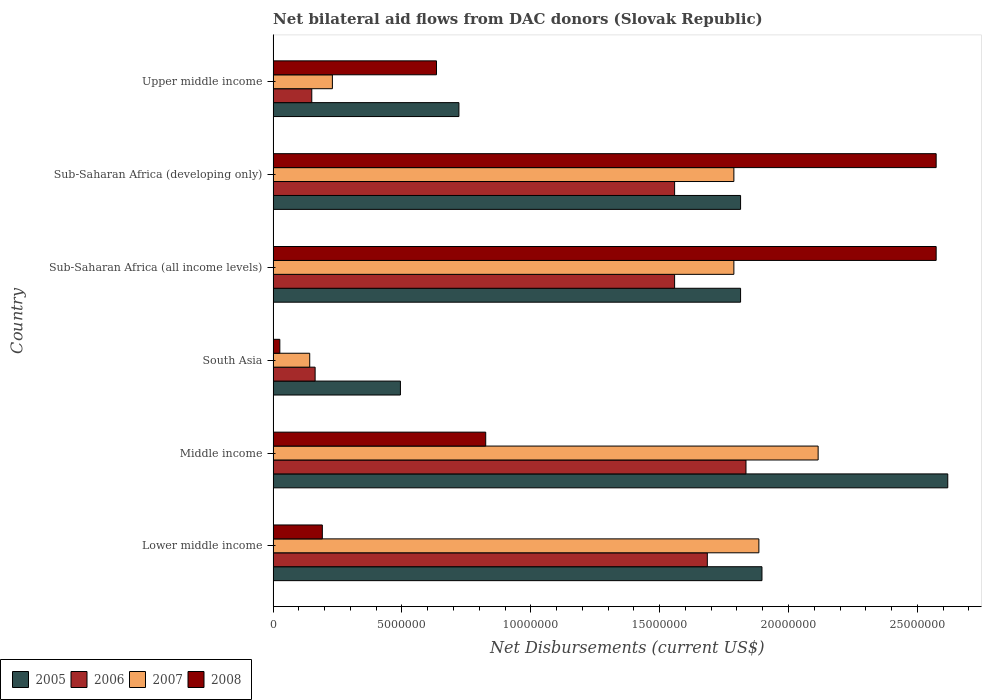How many different coloured bars are there?
Ensure brevity in your answer.  4. Are the number of bars on each tick of the Y-axis equal?
Keep it short and to the point. Yes. In how many cases, is the number of bars for a given country not equal to the number of legend labels?
Ensure brevity in your answer.  0. What is the net bilateral aid flows in 2005 in Upper middle income?
Your response must be concise. 7.21e+06. Across all countries, what is the maximum net bilateral aid flows in 2006?
Your answer should be compact. 1.84e+07. Across all countries, what is the minimum net bilateral aid flows in 2006?
Keep it short and to the point. 1.50e+06. In which country was the net bilateral aid flows in 2006 maximum?
Make the answer very short. Middle income. What is the total net bilateral aid flows in 2007 in the graph?
Offer a very short reply. 7.95e+07. What is the difference between the net bilateral aid flows in 2007 in South Asia and that in Sub-Saharan Africa (all income levels)?
Give a very brief answer. -1.65e+07. What is the difference between the net bilateral aid flows in 2008 in Sub-Saharan Africa (developing only) and the net bilateral aid flows in 2006 in Middle income?
Ensure brevity in your answer.  7.38e+06. What is the average net bilateral aid flows in 2007 per country?
Provide a short and direct response. 1.32e+07. What is the difference between the net bilateral aid flows in 2005 and net bilateral aid flows in 2007 in Sub-Saharan Africa (developing only)?
Provide a short and direct response. 2.60e+05. What is the ratio of the net bilateral aid flows in 2007 in Sub-Saharan Africa (developing only) to that in Upper middle income?
Your response must be concise. 7.77. Is the net bilateral aid flows in 2008 in Sub-Saharan Africa (all income levels) less than that in Sub-Saharan Africa (developing only)?
Make the answer very short. No. Is the difference between the net bilateral aid flows in 2005 in Middle income and Sub-Saharan Africa (all income levels) greater than the difference between the net bilateral aid flows in 2007 in Middle income and Sub-Saharan Africa (all income levels)?
Ensure brevity in your answer.  Yes. What is the difference between the highest and the second highest net bilateral aid flows in 2008?
Provide a short and direct response. 0. What is the difference between the highest and the lowest net bilateral aid flows in 2008?
Make the answer very short. 2.55e+07. In how many countries, is the net bilateral aid flows in 2005 greater than the average net bilateral aid flows in 2005 taken over all countries?
Give a very brief answer. 4. Is it the case that in every country, the sum of the net bilateral aid flows in 2008 and net bilateral aid flows in 2007 is greater than the sum of net bilateral aid flows in 2006 and net bilateral aid flows in 2005?
Offer a very short reply. No. What does the 3rd bar from the top in Sub-Saharan Africa (all income levels) represents?
Keep it short and to the point. 2006. What does the 3rd bar from the bottom in Upper middle income represents?
Make the answer very short. 2007. How many bars are there?
Your response must be concise. 24. How many countries are there in the graph?
Give a very brief answer. 6. Are the values on the major ticks of X-axis written in scientific E-notation?
Your response must be concise. No. Does the graph contain grids?
Offer a very short reply. No. Where does the legend appear in the graph?
Provide a succinct answer. Bottom left. How many legend labels are there?
Provide a succinct answer. 4. How are the legend labels stacked?
Offer a terse response. Horizontal. What is the title of the graph?
Keep it short and to the point. Net bilateral aid flows from DAC donors (Slovak Republic). What is the label or title of the X-axis?
Your answer should be compact. Net Disbursements (current US$). What is the Net Disbursements (current US$) in 2005 in Lower middle income?
Make the answer very short. 1.90e+07. What is the Net Disbursements (current US$) in 2006 in Lower middle income?
Your answer should be compact. 1.68e+07. What is the Net Disbursements (current US$) of 2007 in Lower middle income?
Keep it short and to the point. 1.88e+07. What is the Net Disbursements (current US$) in 2008 in Lower middle income?
Offer a very short reply. 1.91e+06. What is the Net Disbursements (current US$) of 2005 in Middle income?
Give a very brief answer. 2.62e+07. What is the Net Disbursements (current US$) of 2006 in Middle income?
Keep it short and to the point. 1.84e+07. What is the Net Disbursements (current US$) of 2007 in Middle income?
Give a very brief answer. 2.12e+07. What is the Net Disbursements (current US$) of 2008 in Middle income?
Keep it short and to the point. 8.25e+06. What is the Net Disbursements (current US$) of 2005 in South Asia?
Ensure brevity in your answer.  4.94e+06. What is the Net Disbursements (current US$) in 2006 in South Asia?
Give a very brief answer. 1.63e+06. What is the Net Disbursements (current US$) of 2007 in South Asia?
Your answer should be very brief. 1.42e+06. What is the Net Disbursements (current US$) in 2008 in South Asia?
Your answer should be very brief. 2.60e+05. What is the Net Disbursements (current US$) of 2005 in Sub-Saharan Africa (all income levels)?
Offer a very short reply. 1.81e+07. What is the Net Disbursements (current US$) in 2006 in Sub-Saharan Africa (all income levels)?
Make the answer very short. 1.56e+07. What is the Net Disbursements (current US$) of 2007 in Sub-Saharan Africa (all income levels)?
Your answer should be very brief. 1.79e+07. What is the Net Disbursements (current US$) of 2008 in Sub-Saharan Africa (all income levels)?
Your response must be concise. 2.57e+07. What is the Net Disbursements (current US$) in 2005 in Sub-Saharan Africa (developing only)?
Your answer should be very brief. 1.81e+07. What is the Net Disbursements (current US$) of 2006 in Sub-Saharan Africa (developing only)?
Offer a very short reply. 1.56e+07. What is the Net Disbursements (current US$) in 2007 in Sub-Saharan Africa (developing only)?
Your answer should be compact. 1.79e+07. What is the Net Disbursements (current US$) in 2008 in Sub-Saharan Africa (developing only)?
Your answer should be very brief. 2.57e+07. What is the Net Disbursements (current US$) in 2005 in Upper middle income?
Make the answer very short. 7.21e+06. What is the Net Disbursements (current US$) in 2006 in Upper middle income?
Your answer should be very brief. 1.50e+06. What is the Net Disbursements (current US$) in 2007 in Upper middle income?
Provide a succinct answer. 2.30e+06. What is the Net Disbursements (current US$) in 2008 in Upper middle income?
Offer a terse response. 6.34e+06. Across all countries, what is the maximum Net Disbursements (current US$) in 2005?
Your answer should be very brief. 2.62e+07. Across all countries, what is the maximum Net Disbursements (current US$) in 2006?
Make the answer very short. 1.84e+07. Across all countries, what is the maximum Net Disbursements (current US$) in 2007?
Your response must be concise. 2.12e+07. Across all countries, what is the maximum Net Disbursements (current US$) in 2008?
Give a very brief answer. 2.57e+07. Across all countries, what is the minimum Net Disbursements (current US$) of 2005?
Your answer should be compact. 4.94e+06. Across all countries, what is the minimum Net Disbursements (current US$) of 2006?
Your answer should be compact. 1.50e+06. Across all countries, what is the minimum Net Disbursements (current US$) of 2007?
Your answer should be very brief. 1.42e+06. Across all countries, what is the minimum Net Disbursements (current US$) of 2008?
Offer a terse response. 2.60e+05. What is the total Net Disbursements (current US$) in 2005 in the graph?
Your response must be concise. 9.36e+07. What is the total Net Disbursements (current US$) in 2006 in the graph?
Offer a terse response. 6.95e+07. What is the total Net Disbursements (current US$) of 2007 in the graph?
Provide a succinct answer. 7.95e+07. What is the total Net Disbursements (current US$) in 2008 in the graph?
Keep it short and to the point. 6.82e+07. What is the difference between the Net Disbursements (current US$) in 2005 in Lower middle income and that in Middle income?
Offer a very short reply. -7.21e+06. What is the difference between the Net Disbursements (current US$) in 2006 in Lower middle income and that in Middle income?
Your answer should be compact. -1.50e+06. What is the difference between the Net Disbursements (current US$) in 2007 in Lower middle income and that in Middle income?
Your answer should be very brief. -2.30e+06. What is the difference between the Net Disbursements (current US$) of 2008 in Lower middle income and that in Middle income?
Offer a terse response. -6.34e+06. What is the difference between the Net Disbursements (current US$) of 2005 in Lower middle income and that in South Asia?
Keep it short and to the point. 1.40e+07. What is the difference between the Net Disbursements (current US$) in 2006 in Lower middle income and that in South Asia?
Provide a short and direct response. 1.52e+07. What is the difference between the Net Disbursements (current US$) of 2007 in Lower middle income and that in South Asia?
Your response must be concise. 1.74e+07. What is the difference between the Net Disbursements (current US$) of 2008 in Lower middle income and that in South Asia?
Provide a short and direct response. 1.65e+06. What is the difference between the Net Disbursements (current US$) of 2005 in Lower middle income and that in Sub-Saharan Africa (all income levels)?
Make the answer very short. 8.30e+05. What is the difference between the Net Disbursements (current US$) of 2006 in Lower middle income and that in Sub-Saharan Africa (all income levels)?
Your answer should be compact. 1.27e+06. What is the difference between the Net Disbursements (current US$) in 2007 in Lower middle income and that in Sub-Saharan Africa (all income levels)?
Ensure brevity in your answer.  9.70e+05. What is the difference between the Net Disbursements (current US$) of 2008 in Lower middle income and that in Sub-Saharan Africa (all income levels)?
Offer a terse response. -2.38e+07. What is the difference between the Net Disbursements (current US$) in 2005 in Lower middle income and that in Sub-Saharan Africa (developing only)?
Offer a very short reply. 8.30e+05. What is the difference between the Net Disbursements (current US$) in 2006 in Lower middle income and that in Sub-Saharan Africa (developing only)?
Your response must be concise. 1.27e+06. What is the difference between the Net Disbursements (current US$) of 2007 in Lower middle income and that in Sub-Saharan Africa (developing only)?
Your response must be concise. 9.70e+05. What is the difference between the Net Disbursements (current US$) in 2008 in Lower middle income and that in Sub-Saharan Africa (developing only)?
Provide a succinct answer. -2.38e+07. What is the difference between the Net Disbursements (current US$) in 2005 in Lower middle income and that in Upper middle income?
Offer a very short reply. 1.18e+07. What is the difference between the Net Disbursements (current US$) of 2006 in Lower middle income and that in Upper middle income?
Your answer should be very brief. 1.54e+07. What is the difference between the Net Disbursements (current US$) of 2007 in Lower middle income and that in Upper middle income?
Your response must be concise. 1.66e+07. What is the difference between the Net Disbursements (current US$) in 2008 in Lower middle income and that in Upper middle income?
Ensure brevity in your answer.  -4.43e+06. What is the difference between the Net Disbursements (current US$) in 2005 in Middle income and that in South Asia?
Your answer should be compact. 2.12e+07. What is the difference between the Net Disbursements (current US$) of 2006 in Middle income and that in South Asia?
Offer a very short reply. 1.67e+07. What is the difference between the Net Disbursements (current US$) in 2007 in Middle income and that in South Asia?
Your answer should be very brief. 1.97e+07. What is the difference between the Net Disbursements (current US$) in 2008 in Middle income and that in South Asia?
Offer a very short reply. 7.99e+06. What is the difference between the Net Disbursements (current US$) of 2005 in Middle income and that in Sub-Saharan Africa (all income levels)?
Offer a very short reply. 8.04e+06. What is the difference between the Net Disbursements (current US$) of 2006 in Middle income and that in Sub-Saharan Africa (all income levels)?
Your response must be concise. 2.77e+06. What is the difference between the Net Disbursements (current US$) of 2007 in Middle income and that in Sub-Saharan Africa (all income levels)?
Your answer should be compact. 3.27e+06. What is the difference between the Net Disbursements (current US$) in 2008 in Middle income and that in Sub-Saharan Africa (all income levels)?
Make the answer very short. -1.75e+07. What is the difference between the Net Disbursements (current US$) in 2005 in Middle income and that in Sub-Saharan Africa (developing only)?
Offer a very short reply. 8.04e+06. What is the difference between the Net Disbursements (current US$) of 2006 in Middle income and that in Sub-Saharan Africa (developing only)?
Give a very brief answer. 2.77e+06. What is the difference between the Net Disbursements (current US$) of 2007 in Middle income and that in Sub-Saharan Africa (developing only)?
Offer a very short reply. 3.27e+06. What is the difference between the Net Disbursements (current US$) of 2008 in Middle income and that in Sub-Saharan Africa (developing only)?
Ensure brevity in your answer.  -1.75e+07. What is the difference between the Net Disbursements (current US$) of 2005 in Middle income and that in Upper middle income?
Ensure brevity in your answer.  1.90e+07. What is the difference between the Net Disbursements (current US$) of 2006 in Middle income and that in Upper middle income?
Provide a succinct answer. 1.68e+07. What is the difference between the Net Disbursements (current US$) in 2007 in Middle income and that in Upper middle income?
Give a very brief answer. 1.88e+07. What is the difference between the Net Disbursements (current US$) in 2008 in Middle income and that in Upper middle income?
Ensure brevity in your answer.  1.91e+06. What is the difference between the Net Disbursements (current US$) in 2005 in South Asia and that in Sub-Saharan Africa (all income levels)?
Your response must be concise. -1.32e+07. What is the difference between the Net Disbursements (current US$) of 2006 in South Asia and that in Sub-Saharan Africa (all income levels)?
Your answer should be compact. -1.40e+07. What is the difference between the Net Disbursements (current US$) of 2007 in South Asia and that in Sub-Saharan Africa (all income levels)?
Provide a short and direct response. -1.65e+07. What is the difference between the Net Disbursements (current US$) of 2008 in South Asia and that in Sub-Saharan Africa (all income levels)?
Your answer should be compact. -2.55e+07. What is the difference between the Net Disbursements (current US$) of 2005 in South Asia and that in Sub-Saharan Africa (developing only)?
Your answer should be very brief. -1.32e+07. What is the difference between the Net Disbursements (current US$) of 2006 in South Asia and that in Sub-Saharan Africa (developing only)?
Your answer should be very brief. -1.40e+07. What is the difference between the Net Disbursements (current US$) in 2007 in South Asia and that in Sub-Saharan Africa (developing only)?
Your answer should be compact. -1.65e+07. What is the difference between the Net Disbursements (current US$) of 2008 in South Asia and that in Sub-Saharan Africa (developing only)?
Your response must be concise. -2.55e+07. What is the difference between the Net Disbursements (current US$) of 2005 in South Asia and that in Upper middle income?
Your answer should be very brief. -2.27e+06. What is the difference between the Net Disbursements (current US$) of 2006 in South Asia and that in Upper middle income?
Your answer should be very brief. 1.30e+05. What is the difference between the Net Disbursements (current US$) of 2007 in South Asia and that in Upper middle income?
Your answer should be compact. -8.80e+05. What is the difference between the Net Disbursements (current US$) in 2008 in South Asia and that in Upper middle income?
Your answer should be compact. -6.08e+06. What is the difference between the Net Disbursements (current US$) of 2006 in Sub-Saharan Africa (all income levels) and that in Sub-Saharan Africa (developing only)?
Offer a very short reply. 0. What is the difference between the Net Disbursements (current US$) of 2005 in Sub-Saharan Africa (all income levels) and that in Upper middle income?
Offer a terse response. 1.09e+07. What is the difference between the Net Disbursements (current US$) of 2006 in Sub-Saharan Africa (all income levels) and that in Upper middle income?
Make the answer very short. 1.41e+07. What is the difference between the Net Disbursements (current US$) of 2007 in Sub-Saharan Africa (all income levels) and that in Upper middle income?
Offer a very short reply. 1.56e+07. What is the difference between the Net Disbursements (current US$) in 2008 in Sub-Saharan Africa (all income levels) and that in Upper middle income?
Ensure brevity in your answer.  1.94e+07. What is the difference between the Net Disbursements (current US$) of 2005 in Sub-Saharan Africa (developing only) and that in Upper middle income?
Provide a succinct answer. 1.09e+07. What is the difference between the Net Disbursements (current US$) of 2006 in Sub-Saharan Africa (developing only) and that in Upper middle income?
Ensure brevity in your answer.  1.41e+07. What is the difference between the Net Disbursements (current US$) of 2007 in Sub-Saharan Africa (developing only) and that in Upper middle income?
Your answer should be compact. 1.56e+07. What is the difference between the Net Disbursements (current US$) of 2008 in Sub-Saharan Africa (developing only) and that in Upper middle income?
Ensure brevity in your answer.  1.94e+07. What is the difference between the Net Disbursements (current US$) of 2005 in Lower middle income and the Net Disbursements (current US$) of 2006 in Middle income?
Offer a very short reply. 6.20e+05. What is the difference between the Net Disbursements (current US$) of 2005 in Lower middle income and the Net Disbursements (current US$) of 2007 in Middle income?
Your response must be concise. -2.18e+06. What is the difference between the Net Disbursements (current US$) of 2005 in Lower middle income and the Net Disbursements (current US$) of 2008 in Middle income?
Provide a succinct answer. 1.07e+07. What is the difference between the Net Disbursements (current US$) in 2006 in Lower middle income and the Net Disbursements (current US$) in 2007 in Middle income?
Your answer should be compact. -4.30e+06. What is the difference between the Net Disbursements (current US$) of 2006 in Lower middle income and the Net Disbursements (current US$) of 2008 in Middle income?
Your answer should be compact. 8.60e+06. What is the difference between the Net Disbursements (current US$) in 2007 in Lower middle income and the Net Disbursements (current US$) in 2008 in Middle income?
Ensure brevity in your answer.  1.06e+07. What is the difference between the Net Disbursements (current US$) in 2005 in Lower middle income and the Net Disbursements (current US$) in 2006 in South Asia?
Your response must be concise. 1.73e+07. What is the difference between the Net Disbursements (current US$) of 2005 in Lower middle income and the Net Disbursements (current US$) of 2007 in South Asia?
Your response must be concise. 1.76e+07. What is the difference between the Net Disbursements (current US$) in 2005 in Lower middle income and the Net Disbursements (current US$) in 2008 in South Asia?
Your answer should be very brief. 1.87e+07. What is the difference between the Net Disbursements (current US$) of 2006 in Lower middle income and the Net Disbursements (current US$) of 2007 in South Asia?
Make the answer very short. 1.54e+07. What is the difference between the Net Disbursements (current US$) of 2006 in Lower middle income and the Net Disbursements (current US$) of 2008 in South Asia?
Your answer should be very brief. 1.66e+07. What is the difference between the Net Disbursements (current US$) in 2007 in Lower middle income and the Net Disbursements (current US$) in 2008 in South Asia?
Give a very brief answer. 1.86e+07. What is the difference between the Net Disbursements (current US$) in 2005 in Lower middle income and the Net Disbursements (current US$) in 2006 in Sub-Saharan Africa (all income levels)?
Provide a short and direct response. 3.39e+06. What is the difference between the Net Disbursements (current US$) in 2005 in Lower middle income and the Net Disbursements (current US$) in 2007 in Sub-Saharan Africa (all income levels)?
Make the answer very short. 1.09e+06. What is the difference between the Net Disbursements (current US$) in 2005 in Lower middle income and the Net Disbursements (current US$) in 2008 in Sub-Saharan Africa (all income levels)?
Ensure brevity in your answer.  -6.76e+06. What is the difference between the Net Disbursements (current US$) in 2006 in Lower middle income and the Net Disbursements (current US$) in 2007 in Sub-Saharan Africa (all income levels)?
Your response must be concise. -1.03e+06. What is the difference between the Net Disbursements (current US$) of 2006 in Lower middle income and the Net Disbursements (current US$) of 2008 in Sub-Saharan Africa (all income levels)?
Offer a terse response. -8.88e+06. What is the difference between the Net Disbursements (current US$) of 2007 in Lower middle income and the Net Disbursements (current US$) of 2008 in Sub-Saharan Africa (all income levels)?
Ensure brevity in your answer.  -6.88e+06. What is the difference between the Net Disbursements (current US$) in 2005 in Lower middle income and the Net Disbursements (current US$) in 2006 in Sub-Saharan Africa (developing only)?
Ensure brevity in your answer.  3.39e+06. What is the difference between the Net Disbursements (current US$) of 2005 in Lower middle income and the Net Disbursements (current US$) of 2007 in Sub-Saharan Africa (developing only)?
Your response must be concise. 1.09e+06. What is the difference between the Net Disbursements (current US$) of 2005 in Lower middle income and the Net Disbursements (current US$) of 2008 in Sub-Saharan Africa (developing only)?
Make the answer very short. -6.76e+06. What is the difference between the Net Disbursements (current US$) of 2006 in Lower middle income and the Net Disbursements (current US$) of 2007 in Sub-Saharan Africa (developing only)?
Provide a short and direct response. -1.03e+06. What is the difference between the Net Disbursements (current US$) in 2006 in Lower middle income and the Net Disbursements (current US$) in 2008 in Sub-Saharan Africa (developing only)?
Offer a terse response. -8.88e+06. What is the difference between the Net Disbursements (current US$) in 2007 in Lower middle income and the Net Disbursements (current US$) in 2008 in Sub-Saharan Africa (developing only)?
Your response must be concise. -6.88e+06. What is the difference between the Net Disbursements (current US$) in 2005 in Lower middle income and the Net Disbursements (current US$) in 2006 in Upper middle income?
Make the answer very short. 1.75e+07. What is the difference between the Net Disbursements (current US$) of 2005 in Lower middle income and the Net Disbursements (current US$) of 2007 in Upper middle income?
Make the answer very short. 1.67e+07. What is the difference between the Net Disbursements (current US$) of 2005 in Lower middle income and the Net Disbursements (current US$) of 2008 in Upper middle income?
Ensure brevity in your answer.  1.26e+07. What is the difference between the Net Disbursements (current US$) of 2006 in Lower middle income and the Net Disbursements (current US$) of 2007 in Upper middle income?
Your answer should be very brief. 1.46e+07. What is the difference between the Net Disbursements (current US$) of 2006 in Lower middle income and the Net Disbursements (current US$) of 2008 in Upper middle income?
Offer a terse response. 1.05e+07. What is the difference between the Net Disbursements (current US$) of 2007 in Lower middle income and the Net Disbursements (current US$) of 2008 in Upper middle income?
Your response must be concise. 1.25e+07. What is the difference between the Net Disbursements (current US$) of 2005 in Middle income and the Net Disbursements (current US$) of 2006 in South Asia?
Provide a short and direct response. 2.46e+07. What is the difference between the Net Disbursements (current US$) in 2005 in Middle income and the Net Disbursements (current US$) in 2007 in South Asia?
Your response must be concise. 2.48e+07. What is the difference between the Net Disbursements (current US$) of 2005 in Middle income and the Net Disbursements (current US$) of 2008 in South Asia?
Make the answer very short. 2.59e+07. What is the difference between the Net Disbursements (current US$) in 2006 in Middle income and the Net Disbursements (current US$) in 2007 in South Asia?
Offer a very short reply. 1.69e+07. What is the difference between the Net Disbursements (current US$) in 2006 in Middle income and the Net Disbursements (current US$) in 2008 in South Asia?
Provide a succinct answer. 1.81e+07. What is the difference between the Net Disbursements (current US$) in 2007 in Middle income and the Net Disbursements (current US$) in 2008 in South Asia?
Your response must be concise. 2.09e+07. What is the difference between the Net Disbursements (current US$) in 2005 in Middle income and the Net Disbursements (current US$) in 2006 in Sub-Saharan Africa (all income levels)?
Offer a terse response. 1.06e+07. What is the difference between the Net Disbursements (current US$) of 2005 in Middle income and the Net Disbursements (current US$) of 2007 in Sub-Saharan Africa (all income levels)?
Make the answer very short. 8.30e+06. What is the difference between the Net Disbursements (current US$) of 2006 in Middle income and the Net Disbursements (current US$) of 2008 in Sub-Saharan Africa (all income levels)?
Your answer should be very brief. -7.38e+06. What is the difference between the Net Disbursements (current US$) in 2007 in Middle income and the Net Disbursements (current US$) in 2008 in Sub-Saharan Africa (all income levels)?
Make the answer very short. -4.58e+06. What is the difference between the Net Disbursements (current US$) in 2005 in Middle income and the Net Disbursements (current US$) in 2006 in Sub-Saharan Africa (developing only)?
Give a very brief answer. 1.06e+07. What is the difference between the Net Disbursements (current US$) of 2005 in Middle income and the Net Disbursements (current US$) of 2007 in Sub-Saharan Africa (developing only)?
Make the answer very short. 8.30e+06. What is the difference between the Net Disbursements (current US$) of 2006 in Middle income and the Net Disbursements (current US$) of 2007 in Sub-Saharan Africa (developing only)?
Offer a terse response. 4.70e+05. What is the difference between the Net Disbursements (current US$) of 2006 in Middle income and the Net Disbursements (current US$) of 2008 in Sub-Saharan Africa (developing only)?
Provide a short and direct response. -7.38e+06. What is the difference between the Net Disbursements (current US$) of 2007 in Middle income and the Net Disbursements (current US$) of 2008 in Sub-Saharan Africa (developing only)?
Your answer should be very brief. -4.58e+06. What is the difference between the Net Disbursements (current US$) in 2005 in Middle income and the Net Disbursements (current US$) in 2006 in Upper middle income?
Offer a very short reply. 2.47e+07. What is the difference between the Net Disbursements (current US$) of 2005 in Middle income and the Net Disbursements (current US$) of 2007 in Upper middle income?
Your answer should be compact. 2.39e+07. What is the difference between the Net Disbursements (current US$) in 2005 in Middle income and the Net Disbursements (current US$) in 2008 in Upper middle income?
Ensure brevity in your answer.  1.98e+07. What is the difference between the Net Disbursements (current US$) in 2006 in Middle income and the Net Disbursements (current US$) in 2007 in Upper middle income?
Offer a very short reply. 1.60e+07. What is the difference between the Net Disbursements (current US$) in 2006 in Middle income and the Net Disbursements (current US$) in 2008 in Upper middle income?
Your answer should be very brief. 1.20e+07. What is the difference between the Net Disbursements (current US$) of 2007 in Middle income and the Net Disbursements (current US$) of 2008 in Upper middle income?
Give a very brief answer. 1.48e+07. What is the difference between the Net Disbursements (current US$) in 2005 in South Asia and the Net Disbursements (current US$) in 2006 in Sub-Saharan Africa (all income levels)?
Give a very brief answer. -1.06e+07. What is the difference between the Net Disbursements (current US$) in 2005 in South Asia and the Net Disbursements (current US$) in 2007 in Sub-Saharan Africa (all income levels)?
Offer a terse response. -1.29e+07. What is the difference between the Net Disbursements (current US$) in 2005 in South Asia and the Net Disbursements (current US$) in 2008 in Sub-Saharan Africa (all income levels)?
Your answer should be very brief. -2.08e+07. What is the difference between the Net Disbursements (current US$) in 2006 in South Asia and the Net Disbursements (current US$) in 2007 in Sub-Saharan Africa (all income levels)?
Keep it short and to the point. -1.62e+07. What is the difference between the Net Disbursements (current US$) of 2006 in South Asia and the Net Disbursements (current US$) of 2008 in Sub-Saharan Africa (all income levels)?
Provide a succinct answer. -2.41e+07. What is the difference between the Net Disbursements (current US$) of 2007 in South Asia and the Net Disbursements (current US$) of 2008 in Sub-Saharan Africa (all income levels)?
Your answer should be very brief. -2.43e+07. What is the difference between the Net Disbursements (current US$) of 2005 in South Asia and the Net Disbursements (current US$) of 2006 in Sub-Saharan Africa (developing only)?
Provide a short and direct response. -1.06e+07. What is the difference between the Net Disbursements (current US$) of 2005 in South Asia and the Net Disbursements (current US$) of 2007 in Sub-Saharan Africa (developing only)?
Provide a succinct answer. -1.29e+07. What is the difference between the Net Disbursements (current US$) in 2005 in South Asia and the Net Disbursements (current US$) in 2008 in Sub-Saharan Africa (developing only)?
Ensure brevity in your answer.  -2.08e+07. What is the difference between the Net Disbursements (current US$) in 2006 in South Asia and the Net Disbursements (current US$) in 2007 in Sub-Saharan Africa (developing only)?
Your response must be concise. -1.62e+07. What is the difference between the Net Disbursements (current US$) in 2006 in South Asia and the Net Disbursements (current US$) in 2008 in Sub-Saharan Africa (developing only)?
Provide a succinct answer. -2.41e+07. What is the difference between the Net Disbursements (current US$) in 2007 in South Asia and the Net Disbursements (current US$) in 2008 in Sub-Saharan Africa (developing only)?
Offer a very short reply. -2.43e+07. What is the difference between the Net Disbursements (current US$) in 2005 in South Asia and the Net Disbursements (current US$) in 2006 in Upper middle income?
Keep it short and to the point. 3.44e+06. What is the difference between the Net Disbursements (current US$) of 2005 in South Asia and the Net Disbursements (current US$) of 2007 in Upper middle income?
Keep it short and to the point. 2.64e+06. What is the difference between the Net Disbursements (current US$) in 2005 in South Asia and the Net Disbursements (current US$) in 2008 in Upper middle income?
Provide a succinct answer. -1.40e+06. What is the difference between the Net Disbursements (current US$) in 2006 in South Asia and the Net Disbursements (current US$) in 2007 in Upper middle income?
Give a very brief answer. -6.70e+05. What is the difference between the Net Disbursements (current US$) of 2006 in South Asia and the Net Disbursements (current US$) of 2008 in Upper middle income?
Offer a terse response. -4.71e+06. What is the difference between the Net Disbursements (current US$) of 2007 in South Asia and the Net Disbursements (current US$) of 2008 in Upper middle income?
Give a very brief answer. -4.92e+06. What is the difference between the Net Disbursements (current US$) in 2005 in Sub-Saharan Africa (all income levels) and the Net Disbursements (current US$) in 2006 in Sub-Saharan Africa (developing only)?
Your answer should be compact. 2.56e+06. What is the difference between the Net Disbursements (current US$) in 2005 in Sub-Saharan Africa (all income levels) and the Net Disbursements (current US$) in 2008 in Sub-Saharan Africa (developing only)?
Your response must be concise. -7.59e+06. What is the difference between the Net Disbursements (current US$) in 2006 in Sub-Saharan Africa (all income levels) and the Net Disbursements (current US$) in 2007 in Sub-Saharan Africa (developing only)?
Give a very brief answer. -2.30e+06. What is the difference between the Net Disbursements (current US$) in 2006 in Sub-Saharan Africa (all income levels) and the Net Disbursements (current US$) in 2008 in Sub-Saharan Africa (developing only)?
Make the answer very short. -1.02e+07. What is the difference between the Net Disbursements (current US$) in 2007 in Sub-Saharan Africa (all income levels) and the Net Disbursements (current US$) in 2008 in Sub-Saharan Africa (developing only)?
Offer a terse response. -7.85e+06. What is the difference between the Net Disbursements (current US$) of 2005 in Sub-Saharan Africa (all income levels) and the Net Disbursements (current US$) of 2006 in Upper middle income?
Your response must be concise. 1.66e+07. What is the difference between the Net Disbursements (current US$) in 2005 in Sub-Saharan Africa (all income levels) and the Net Disbursements (current US$) in 2007 in Upper middle income?
Keep it short and to the point. 1.58e+07. What is the difference between the Net Disbursements (current US$) of 2005 in Sub-Saharan Africa (all income levels) and the Net Disbursements (current US$) of 2008 in Upper middle income?
Provide a succinct answer. 1.18e+07. What is the difference between the Net Disbursements (current US$) of 2006 in Sub-Saharan Africa (all income levels) and the Net Disbursements (current US$) of 2007 in Upper middle income?
Your response must be concise. 1.33e+07. What is the difference between the Net Disbursements (current US$) of 2006 in Sub-Saharan Africa (all income levels) and the Net Disbursements (current US$) of 2008 in Upper middle income?
Offer a terse response. 9.24e+06. What is the difference between the Net Disbursements (current US$) in 2007 in Sub-Saharan Africa (all income levels) and the Net Disbursements (current US$) in 2008 in Upper middle income?
Your answer should be very brief. 1.15e+07. What is the difference between the Net Disbursements (current US$) of 2005 in Sub-Saharan Africa (developing only) and the Net Disbursements (current US$) of 2006 in Upper middle income?
Your answer should be very brief. 1.66e+07. What is the difference between the Net Disbursements (current US$) in 2005 in Sub-Saharan Africa (developing only) and the Net Disbursements (current US$) in 2007 in Upper middle income?
Provide a succinct answer. 1.58e+07. What is the difference between the Net Disbursements (current US$) of 2005 in Sub-Saharan Africa (developing only) and the Net Disbursements (current US$) of 2008 in Upper middle income?
Make the answer very short. 1.18e+07. What is the difference between the Net Disbursements (current US$) of 2006 in Sub-Saharan Africa (developing only) and the Net Disbursements (current US$) of 2007 in Upper middle income?
Your answer should be compact. 1.33e+07. What is the difference between the Net Disbursements (current US$) in 2006 in Sub-Saharan Africa (developing only) and the Net Disbursements (current US$) in 2008 in Upper middle income?
Offer a terse response. 9.24e+06. What is the difference between the Net Disbursements (current US$) in 2007 in Sub-Saharan Africa (developing only) and the Net Disbursements (current US$) in 2008 in Upper middle income?
Your answer should be very brief. 1.15e+07. What is the average Net Disbursements (current US$) in 2005 per country?
Make the answer very short. 1.56e+07. What is the average Net Disbursements (current US$) in 2006 per country?
Give a very brief answer. 1.16e+07. What is the average Net Disbursements (current US$) of 2007 per country?
Offer a very short reply. 1.32e+07. What is the average Net Disbursements (current US$) in 2008 per country?
Provide a short and direct response. 1.14e+07. What is the difference between the Net Disbursements (current US$) of 2005 and Net Disbursements (current US$) of 2006 in Lower middle income?
Make the answer very short. 2.12e+06. What is the difference between the Net Disbursements (current US$) in 2005 and Net Disbursements (current US$) in 2007 in Lower middle income?
Give a very brief answer. 1.20e+05. What is the difference between the Net Disbursements (current US$) in 2005 and Net Disbursements (current US$) in 2008 in Lower middle income?
Keep it short and to the point. 1.71e+07. What is the difference between the Net Disbursements (current US$) of 2006 and Net Disbursements (current US$) of 2007 in Lower middle income?
Make the answer very short. -2.00e+06. What is the difference between the Net Disbursements (current US$) of 2006 and Net Disbursements (current US$) of 2008 in Lower middle income?
Make the answer very short. 1.49e+07. What is the difference between the Net Disbursements (current US$) in 2007 and Net Disbursements (current US$) in 2008 in Lower middle income?
Your answer should be compact. 1.69e+07. What is the difference between the Net Disbursements (current US$) of 2005 and Net Disbursements (current US$) of 2006 in Middle income?
Make the answer very short. 7.83e+06. What is the difference between the Net Disbursements (current US$) of 2005 and Net Disbursements (current US$) of 2007 in Middle income?
Your answer should be compact. 5.03e+06. What is the difference between the Net Disbursements (current US$) of 2005 and Net Disbursements (current US$) of 2008 in Middle income?
Ensure brevity in your answer.  1.79e+07. What is the difference between the Net Disbursements (current US$) of 2006 and Net Disbursements (current US$) of 2007 in Middle income?
Your answer should be very brief. -2.80e+06. What is the difference between the Net Disbursements (current US$) of 2006 and Net Disbursements (current US$) of 2008 in Middle income?
Make the answer very short. 1.01e+07. What is the difference between the Net Disbursements (current US$) in 2007 and Net Disbursements (current US$) in 2008 in Middle income?
Your response must be concise. 1.29e+07. What is the difference between the Net Disbursements (current US$) in 2005 and Net Disbursements (current US$) in 2006 in South Asia?
Provide a succinct answer. 3.31e+06. What is the difference between the Net Disbursements (current US$) in 2005 and Net Disbursements (current US$) in 2007 in South Asia?
Make the answer very short. 3.52e+06. What is the difference between the Net Disbursements (current US$) of 2005 and Net Disbursements (current US$) of 2008 in South Asia?
Your answer should be very brief. 4.68e+06. What is the difference between the Net Disbursements (current US$) in 2006 and Net Disbursements (current US$) in 2008 in South Asia?
Give a very brief answer. 1.37e+06. What is the difference between the Net Disbursements (current US$) in 2007 and Net Disbursements (current US$) in 2008 in South Asia?
Your answer should be compact. 1.16e+06. What is the difference between the Net Disbursements (current US$) of 2005 and Net Disbursements (current US$) of 2006 in Sub-Saharan Africa (all income levels)?
Ensure brevity in your answer.  2.56e+06. What is the difference between the Net Disbursements (current US$) of 2005 and Net Disbursements (current US$) of 2008 in Sub-Saharan Africa (all income levels)?
Keep it short and to the point. -7.59e+06. What is the difference between the Net Disbursements (current US$) in 2006 and Net Disbursements (current US$) in 2007 in Sub-Saharan Africa (all income levels)?
Provide a succinct answer. -2.30e+06. What is the difference between the Net Disbursements (current US$) of 2006 and Net Disbursements (current US$) of 2008 in Sub-Saharan Africa (all income levels)?
Make the answer very short. -1.02e+07. What is the difference between the Net Disbursements (current US$) in 2007 and Net Disbursements (current US$) in 2008 in Sub-Saharan Africa (all income levels)?
Keep it short and to the point. -7.85e+06. What is the difference between the Net Disbursements (current US$) in 2005 and Net Disbursements (current US$) in 2006 in Sub-Saharan Africa (developing only)?
Make the answer very short. 2.56e+06. What is the difference between the Net Disbursements (current US$) of 2005 and Net Disbursements (current US$) of 2008 in Sub-Saharan Africa (developing only)?
Provide a short and direct response. -7.59e+06. What is the difference between the Net Disbursements (current US$) of 2006 and Net Disbursements (current US$) of 2007 in Sub-Saharan Africa (developing only)?
Your response must be concise. -2.30e+06. What is the difference between the Net Disbursements (current US$) of 2006 and Net Disbursements (current US$) of 2008 in Sub-Saharan Africa (developing only)?
Offer a terse response. -1.02e+07. What is the difference between the Net Disbursements (current US$) of 2007 and Net Disbursements (current US$) of 2008 in Sub-Saharan Africa (developing only)?
Ensure brevity in your answer.  -7.85e+06. What is the difference between the Net Disbursements (current US$) in 2005 and Net Disbursements (current US$) in 2006 in Upper middle income?
Give a very brief answer. 5.71e+06. What is the difference between the Net Disbursements (current US$) of 2005 and Net Disbursements (current US$) of 2007 in Upper middle income?
Keep it short and to the point. 4.91e+06. What is the difference between the Net Disbursements (current US$) in 2005 and Net Disbursements (current US$) in 2008 in Upper middle income?
Your response must be concise. 8.70e+05. What is the difference between the Net Disbursements (current US$) in 2006 and Net Disbursements (current US$) in 2007 in Upper middle income?
Ensure brevity in your answer.  -8.00e+05. What is the difference between the Net Disbursements (current US$) in 2006 and Net Disbursements (current US$) in 2008 in Upper middle income?
Ensure brevity in your answer.  -4.84e+06. What is the difference between the Net Disbursements (current US$) in 2007 and Net Disbursements (current US$) in 2008 in Upper middle income?
Provide a succinct answer. -4.04e+06. What is the ratio of the Net Disbursements (current US$) of 2005 in Lower middle income to that in Middle income?
Offer a terse response. 0.72. What is the ratio of the Net Disbursements (current US$) of 2006 in Lower middle income to that in Middle income?
Make the answer very short. 0.92. What is the ratio of the Net Disbursements (current US$) of 2007 in Lower middle income to that in Middle income?
Provide a succinct answer. 0.89. What is the ratio of the Net Disbursements (current US$) in 2008 in Lower middle income to that in Middle income?
Give a very brief answer. 0.23. What is the ratio of the Net Disbursements (current US$) of 2005 in Lower middle income to that in South Asia?
Your response must be concise. 3.84. What is the ratio of the Net Disbursements (current US$) of 2006 in Lower middle income to that in South Asia?
Provide a short and direct response. 10.34. What is the ratio of the Net Disbursements (current US$) of 2007 in Lower middle income to that in South Asia?
Provide a short and direct response. 13.27. What is the ratio of the Net Disbursements (current US$) of 2008 in Lower middle income to that in South Asia?
Your response must be concise. 7.35. What is the ratio of the Net Disbursements (current US$) in 2005 in Lower middle income to that in Sub-Saharan Africa (all income levels)?
Keep it short and to the point. 1.05. What is the ratio of the Net Disbursements (current US$) in 2006 in Lower middle income to that in Sub-Saharan Africa (all income levels)?
Keep it short and to the point. 1.08. What is the ratio of the Net Disbursements (current US$) in 2007 in Lower middle income to that in Sub-Saharan Africa (all income levels)?
Keep it short and to the point. 1.05. What is the ratio of the Net Disbursements (current US$) of 2008 in Lower middle income to that in Sub-Saharan Africa (all income levels)?
Provide a short and direct response. 0.07. What is the ratio of the Net Disbursements (current US$) in 2005 in Lower middle income to that in Sub-Saharan Africa (developing only)?
Give a very brief answer. 1.05. What is the ratio of the Net Disbursements (current US$) of 2006 in Lower middle income to that in Sub-Saharan Africa (developing only)?
Make the answer very short. 1.08. What is the ratio of the Net Disbursements (current US$) in 2007 in Lower middle income to that in Sub-Saharan Africa (developing only)?
Make the answer very short. 1.05. What is the ratio of the Net Disbursements (current US$) in 2008 in Lower middle income to that in Sub-Saharan Africa (developing only)?
Keep it short and to the point. 0.07. What is the ratio of the Net Disbursements (current US$) of 2005 in Lower middle income to that in Upper middle income?
Make the answer very short. 2.63. What is the ratio of the Net Disbursements (current US$) of 2006 in Lower middle income to that in Upper middle income?
Ensure brevity in your answer.  11.23. What is the ratio of the Net Disbursements (current US$) of 2007 in Lower middle income to that in Upper middle income?
Offer a terse response. 8.2. What is the ratio of the Net Disbursements (current US$) of 2008 in Lower middle income to that in Upper middle income?
Make the answer very short. 0.3. What is the ratio of the Net Disbursements (current US$) in 2005 in Middle income to that in South Asia?
Offer a terse response. 5.3. What is the ratio of the Net Disbursements (current US$) in 2006 in Middle income to that in South Asia?
Offer a very short reply. 11.26. What is the ratio of the Net Disbursements (current US$) of 2007 in Middle income to that in South Asia?
Keep it short and to the point. 14.89. What is the ratio of the Net Disbursements (current US$) in 2008 in Middle income to that in South Asia?
Your answer should be very brief. 31.73. What is the ratio of the Net Disbursements (current US$) of 2005 in Middle income to that in Sub-Saharan Africa (all income levels)?
Your answer should be compact. 1.44. What is the ratio of the Net Disbursements (current US$) of 2006 in Middle income to that in Sub-Saharan Africa (all income levels)?
Ensure brevity in your answer.  1.18. What is the ratio of the Net Disbursements (current US$) in 2007 in Middle income to that in Sub-Saharan Africa (all income levels)?
Keep it short and to the point. 1.18. What is the ratio of the Net Disbursements (current US$) in 2008 in Middle income to that in Sub-Saharan Africa (all income levels)?
Offer a very short reply. 0.32. What is the ratio of the Net Disbursements (current US$) in 2005 in Middle income to that in Sub-Saharan Africa (developing only)?
Ensure brevity in your answer.  1.44. What is the ratio of the Net Disbursements (current US$) of 2006 in Middle income to that in Sub-Saharan Africa (developing only)?
Keep it short and to the point. 1.18. What is the ratio of the Net Disbursements (current US$) in 2007 in Middle income to that in Sub-Saharan Africa (developing only)?
Give a very brief answer. 1.18. What is the ratio of the Net Disbursements (current US$) in 2008 in Middle income to that in Sub-Saharan Africa (developing only)?
Provide a succinct answer. 0.32. What is the ratio of the Net Disbursements (current US$) in 2005 in Middle income to that in Upper middle income?
Offer a terse response. 3.63. What is the ratio of the Net Disbursements (current US$) of 2006 in Middle income to that in Upper middle income?
Give a very brief answer. 12.23. What is the ratio of the Net Disbursements (current US$) of 2007 in Middle income to that in Upper middle income?
Provide a short and direct response. 9.2. What is the ratio of the Net Disbursements (current US$) in 2008 in Middle income to that in Upper middle income?
Give a very brief answer. 1.3. What is the ratio of the Net Disbursements (current US$) in 2005 in South Asia to that in Sub-Saharan Africa (all income levels)?
Provide a succinct answer. 0.27. What is the ratio of the Net Disbursements (current US$) in 2006 in South Asia to that in Sub-Saharan Africa (all income levels)?
Provide a short and direct response. 0.1. What is the ratio of the Net Disbursements (current US$) in 2007 in South Asia to that in Sub-Saharan Africa (all income levels)?
Offer a terse response. 0.08. What is the ratio of the Net Disbursements (current US$) of 2008 in South Asia to that in Sub-Saharan Africa (all income levels)?
Give a very brief answer. 0.01. What is the ratio of the Net Disbursements (current US$) in 2005 in South Asia to that in Sub-Saharan Africa (developing only)?
Provide a short and direct response. 0.27. What is the ratio of the Net Disbursements (current US$) in 2006 in South Asia to that in Sub-Saharan Africa (developing only)?
Your answer should be compact. 0.1. What is the ratio of the Net Disbursements (current US$) in 2007 in South Asia to that in Sub-Saharan Africa (developing only)?
Offer a terse response. 0.08. What is the ratio of the Net Disbursements (current US$) of 2008 in South Asia to that in Sub-Saharan Africa (developing only)?
Give a very brief answer. 0.01. What is the ratio of the Net Disbursements (current US$) in 2005 in South Asia to that in Upper middle income?
Your answer should be compact. 0.69. What is the ratio of the Net Disbursements (current US$) of 2006 in South Asia to that in Upper middle income?
Provide a short and direct response. 1.09. What is the ratio of the Net Disbursements (current US$) of 2007 in South Asia to that in Upper middle income?
Provide a succinct answer. 0.62. What is the ratio of the Net Disbursements (current US$) in 2008 in South Asia to that in Upper middle income?
Offer a very short reply. 0.04. What is the ratio of the Net Disbursements (current US$) of 2005 in Sub-Saharan Africa (all income levels) to that in Upper middle income?
Provide a short and direct response. 2.52. What is the ratio of the Net Disbursements (current US$) of 2006 in Sub-Saharan Africa (all income levels) to that in Upper middle income?
Your answer should be very brief. 10.39. What is the ratio of the Net Disbursements (current US$) in 2007 in Sub-Saharan Africa (all income levels) to that in Upper middle income?
Your answer should be compact. 7.77. What is the ratio of the Net Disbursements (current US$) of 2008 in Sub-Saharan Africa (all income levels) to that in Upper middle income?
Give a very brief answer. 4.06. What is the ratio of the Net Disbursements (current US$) in 2005 in Sub-Saharan Africa (developing only) to that in Upper middle income?
Offer a very short reply. 2.52. What is the ratio of the Net Disbursements (current US$) in 2006 in Sub-Saharan Africa (developing only) to that in Upper middle income?
Offer a terse response. 10.39. What is the ratio of the Net Disbursements (current US$) in 2007 in Sub-Saharan Africa (developing only) to that in Upper middle income?
Give a very brief answer. 7.77. What is the ratio of the Net Disbursements (current US$) in 2008 in Sub-Saharan Africa (developing only) to that in Upper middle income?
Provide a short and direct response. 4.06. What is the difference between the highest and the second highest Net Disbursements (current US$) in 2005?
Ensure brevity in your answer.  7.21e+06. What is the difference between the highest and the second highest Net Disbursements (current US$) of 2006?
Make the answer very short. 1.50e+06. What is the difference between the highest and the second highest Net Disbursements (current US$) of 2007?
Your response must be concise. 2.30e+06. What is the difference between the highest and the lowest Net Disbursements (current US$) of 2005?
Provide a succinct answer. 2.12e+07. What is the difference between the highest and the lowest Net Disbursements (current US$) of 2006?
Your response must be concise. 1.68e+07. What is the difference between the highest and the lowest Net Disbursements (current US$) in 2007?
Provide a short and direct response. 1.97e+07. What is the difference between the highest and the lowest Net Disbursements (current US$) of 2008?
Offer a very short reply. 2.55e+07. 